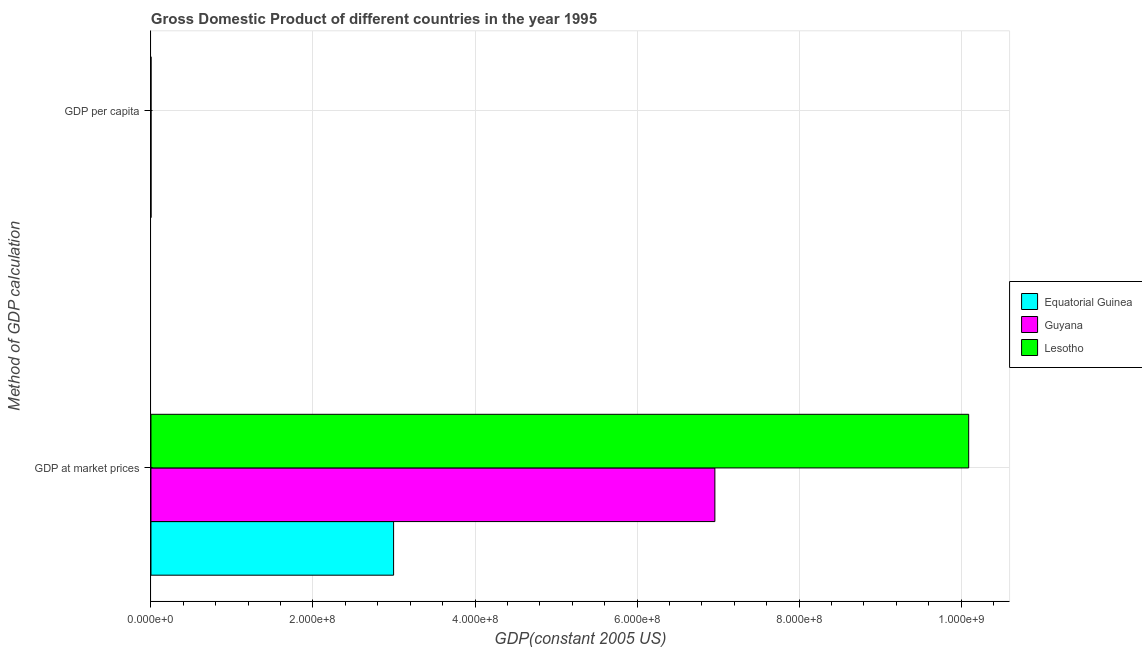How many different coloured bars are there?
Ensure brevity in your answer.  3. How many groups of bars are there?
Give a very brief answer. 2. Are the number of bars per tick equal to the number of legend labels?
Your answer should be very brief. Yes. Are the number of bars on each tick of the Y-axis equal?
Provide a short and direct response. Yes. How many bars are there on the 1st tick from the top?
Offer a terse response. 3. How many bars are there on the 1st tick from the bottom?
Provide a short and direct response. 3. What is the label of the 1st group of bars from the top?
Your answer should be very brief. GDP per capita. What is the gdp at market prices in Lesotho?
Provide a succinct answer. 1.01e+09. Across all countries, what is the maximum gdp at market prices?
Ensure brevity in your answer.  1.01e+09. Across all countries, what is the minimum gdp per capita?
Offer a terse response. 575.56. In which country was the gdp at market prices maximum?
Keep it short and to the point. Lesotho. In which country was the gdp at market prices minimum?
Your answer should be compact. Equatorial Guinea. What is the total gdp per capita in the graph?
Provide a short and direct response. 2201.56. What is the difference between the gdp per capita in Guyana and that in Equatorial Guinea?
Provide a short and direct response. 289.88. What is the difference between the gdp at market prices in Guyana and the gdp per capita in Lesotho?
Keep it short and to the point. 6.96e+08. What is the average gdp per capita per country?
Offer a terse response. 733.85. What is the difference between the gdp at market prices and gdp per capita in Lesotho?
Give a very brief answer. 1.01e+09. What is the ratio of the gdp at market prices in Equatorial Guinea to that in Guyana?
Your answer should be compact. 0.43. What does the 2nd bar from the top in GDP at market prices represents?
Give a very brief answer. Guyana. What does the 3rd bar from the bottom in GDP per capita represents?
Your response must be concise. Lesotho. How many bars are there?
Keep it short and to the point. 6. Are all the bars in the graph horizontal?
Provide a short and direct response. Yes. How many countries are there in the graph?
Offer a very short reply. 3. What is the difference between two consecutive major ticks on the X-axis?
Your answer should be very brief. 2.00e+08. Where does the legend appear in the graph?
Give a very brief answer. Center right. How are the legend labels stacked?
Your response must be concise. Vertical. What is the title of the graph?
Your response must be concise. Gross Domestic Product of different countries in the year 1995. What is the label or title of the X-axis?
Provide a succinct answer. GDP(constant 2005 US). What is the label or title of the Y-axis?
Ensure brevity in your answer.  Method of GDP calculation. What is the GDP(constant 2005 US) in Equatorial Guinea in GDP at market prices?
Make the answer very short. 3.00e+08. What is the GDP(constant 2005 US) of Guyana in GDP at market prices?
Ensure brevity in your answer.  6.96e+08. What is the GDP(constant 2005 US) of Lesotho in GDP at market prices?
Offer a very short reply. 1.01e+09. What is the GDP(constant 2005 US) in Equatorial Guinea in GDP per capita?
Provide a short and direct response. 668.06. What is the GDP(constant 2005 US) of Guyana in GDP per capita?
Give a very brief answer. 957.94. What is the GDP(constant 2005 US) of Lesotho in GDP per capita?
Make the answer very short. 575.56. Across all Method of GDP calculation, what is the maximum GDP(constant 2005 US) of Equatorial Guinea?
Provide a short and direct response. 3.00e+08. Across all Method of GDP calculation, what is the maximum GDP(constant 2005 US) in Guyana?
Your response must be concise. 6.96e+08. Across all Method of GDP calculation, what is the maximum GDP(constant 2005 US) in Lesotho?
Offer a very short reply. 1.01e+09. Across all Method of GDP calculation, what is the minimum GDP(constant 2005 US) in Equatorial Guinea?
Make the answer very short. 668.06. Across all Method of GDP calculation, what is the minimum GDP(constant 2005 US) in Guyana?
Offer a terse response. 957.94. Across all Method of GDP calculation, what is the minimum GDP(constant 2005 US) in Lesotho?
Your answer should be compact. 575.56. What is the total GDP(constant 2005 US) of Equatorial Guinea in the graph?
Your answer should be very brief. 3.00e+08. What is the total GDP(constant 2005 US) of Guyana in the graph?
Your response must be concise. 6.96e+08. What is the total GDP(constant 2005 US) in Lesotho in the graph?
Your answer should be compact. 1.01e+09. What is the difference between the GDP(constant 2005 US) of Equatorial Guinea in GDP at market prices and that in GDP per capita?
Your answer should be compact. 3.00e+08. What is the difference between the GDP(constant 2005 US) in Guyana in GDP at market prices and that in GDP per capita?
Your response must be concise. 6.96e+08. What is the difference between the GDP(constant 2005 US) in Lesotho in GDP at market prices and that in GDP per capita?
Give a very brief answer. 1.01e+09. What is the difference between the GDP(constant 2005 US) of Equatorial Guinea in GDP at market prices and the GDP(constant 2005 US) of Guyana in GDP per capita?
Offer a very short reply. 3.00e+08. What is the difference between the GDP(constant 2005 US) in Equatorial Guinea in GDP at market prices and the GDP(constant 2005 US) in Lesotho in GDP per capita?
Offer a very short reply. 3.00e+08. What is the difference between the GDP(constant 2005 US) of Guyana in GDP at market prices and the GDP(constant 2005 US) of Lesotho in GDP per capita?
Provide a short and direct response. 6.96e+08. What is the average GDP(constant 2005 US) of Equatorial Guinea per Method of GDP calculation?
Provide a short and direct response. 1.50e+08. What is the average GDP(constant 2005 US) in Guyana per Method of GDP calculation?
Offer a terse response. 3.48e+08. What is the average GDP(constant 2005 US) of Lesotho per Method of GDP calculation?
Keep it short and to the point. 5.05e+08. What is the difference between the GDP(constant 2005 US) in Equatorial Guinea and GDP(constant 2005 US) in Guyana in GDP at market prices?
Your answer should be compact. -3.97e+08. What is the difference between the GDP(constant 2005 US) in Equatorial Guinea and GDP(constant 2005 US) in Lesotho in GDP at market prices?
Your answer should be compact. -7.10e+08. What is the difference between the GDP(constant 2005 US) in Guyana and GDP(constant 2005 US) in Lesotho in GDP at market prices?
Offer a terse response. -3.13e+08. What is the difference between the GDP(constant 2005 US) of Equatorial Guinea and GDP(constant 2005 US) of Guyana in GDP per capita?
Ensure brevity in your answer.  -289.88. What is the difference between the GDP(constant 2005 US) in Equatorial Guinea and GDP(constant 2005 US) in Lesotho in GDP per capita?
Your answer should be compact. 92.49. What is the difference between the GDP(constant 2005 US) in Guyana and GDP(constant 2005 US) in Lesotho in GDP per capita?
Your response must be concise. 382.37. What is the ratio of the GDP(constant 2005 US) of Equatorial Guinea in GDP at market prices to that in GDP per capita?
Offer a terse response. 4.48e+05. What is the ratio of the GDP(constant 2005 US) in Guyana in GDP at market prices to that in GDP per capita?
Your answer should be compact. 7.27e+05. What is the ratio of the GDP(constant 2005 US) of Lesotho in GDP at market prices to that in GDP per capita?
Give a very brief answer. 1.75e+06. What is the difference between the highest and the second highest GDP(constant 2005 US) of Equatorial Guinea?
Your answer should be compact. 3.00e+08. What is the difference between the highest and the second highest GDP(constant 2005 US) in Guyana?
Provide a short and direct response. 6.96e+08. What is the difference between the highest and the second highest GDP(constant 2005 US) in Lesotho?
Provide a short and direct response. 1.01e+09. What is the difference between the highest and the lowest GDP(constant 2005 US) of Equatorial Guinea?
Make the answer very short. 3.00e+08. What is the difference between the highest and the lowest GDP(constant 2005 US) in Guyana?
Your answer should be very brief. 6.96e+08. What is the difference between the highest and the lowest GDP(constant 2005 US) of Lesotho?
Provide a succinct answer. 1.01e+09. 